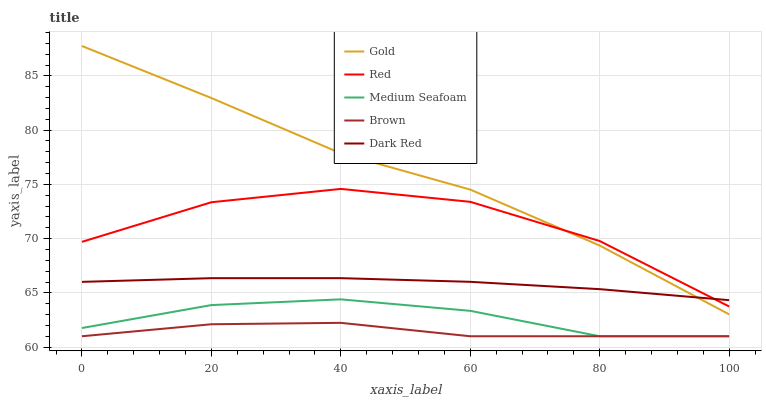Does Brown have the minimum area under the curve?
Answer yes or no. Yes. Does Gold have the maximum area under the curve?
Answer yes or no. Yes. Does Dark Red have the minimum area under the curve?
Answer yes or no. No. Does Dark Red have the maximum area under the curve?
Answer yes or no. No. Is Dark Red the smoothest?
Answer yes or no. Yes. Is Red the roughest?
Answer yes or no. Yes. Is Red the smoothest?
Answer yes or no. No. Is Dark Red the roughest?
Answer yes or no. No. Does Brown have the lowest value?
Answer yes or no. Yes. Does Red have the lowest value?
Answer yes or no. No. Does Gold have the highest value?
Answer yes or no. Yes. Does Dark Red have the highest value?
Answer yes or no. No. Is Brown less than Red?
Answer yes or no. Yes. Is Red greater than Medium Seafoam?
Answer yes or no. Yes. Does Gold intersect Dark Red?
Answer yes or no. Yes. Is Gold less than Dark Red?
Answer yes or no. No. Is Gold greater than Dark Red?
Answer yes or no. No. Does Brown intersect Red?
Answer yes or no. No. 